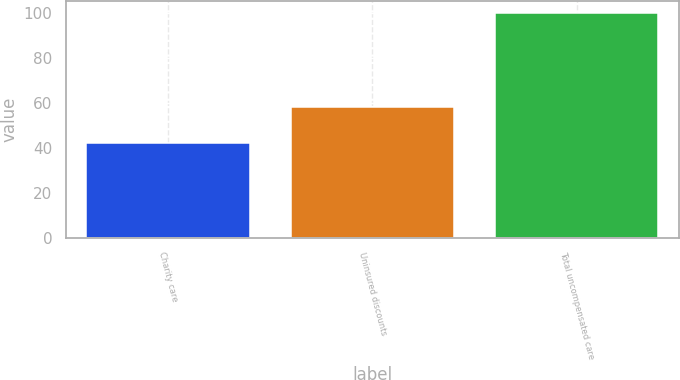Convert chart to OTSL. <chart><loc_0><loc_0><loc_500><loc_500><bar_chart><fcel>Charity care<fcel>Uninsured discounts<fcel>Total uncompensated care<nl><fcel>42<fcel>58<fcel>100<nl></chart> 